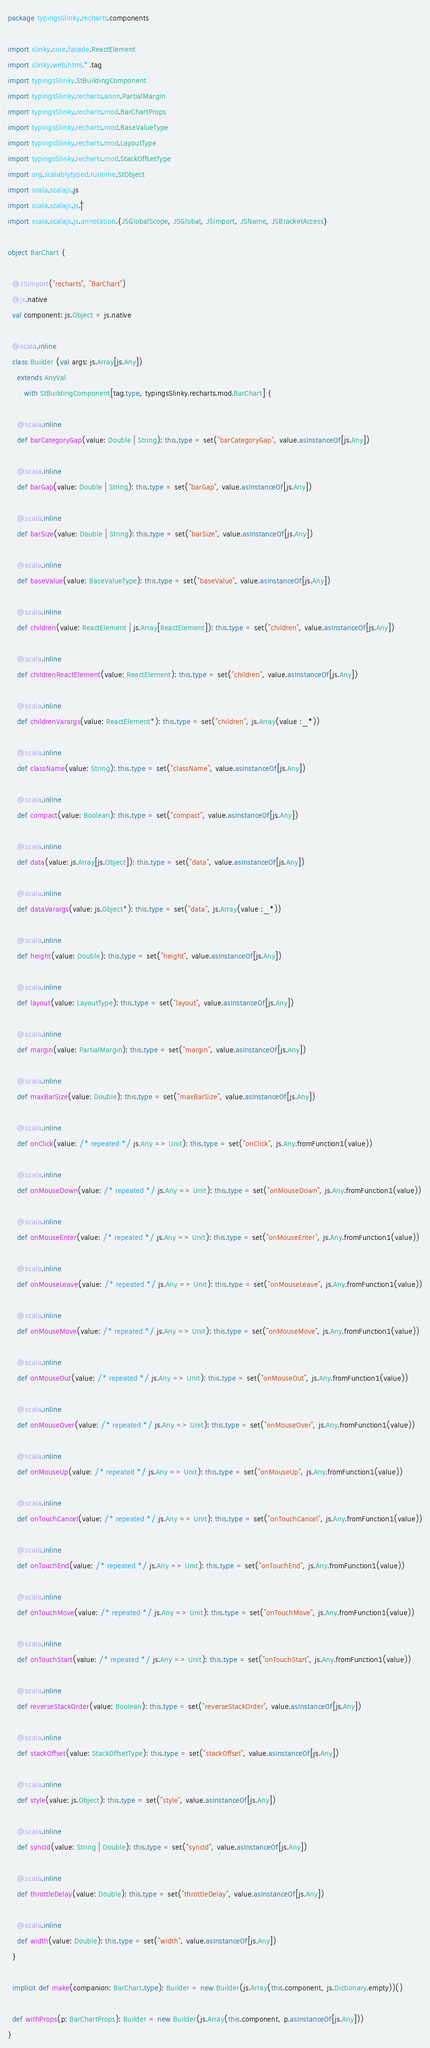<code> <loc_0><loc_0><loc_500><loc_500><_Scala_>package typingsSlinky.recharts.components

import slinky.core.facade.ReactElement
import slinky.web.html.`*`.tag
import typingsSlinky.StBuildingComponent
import typingsSlinky.recharts.anon.PartialMargin
import typingsSlinky.recharts.mod.BarChartProps
import typingsSlinky.recharts.mod.BaseValueType
import typingsSlinky.recharts.mod.LayoutType
import typingsSlinky.recharts.mod.StackOffsetType
import org.scalablytyped.runtime.StObject
import scala.scalajs.js
import scala.scalajs.js.`|`
import scala.scalajs.js.annotation.{JSGlobalScope, JSGlobal, JSImport, JSName, JSBracketAccess}

object BarChart {
  
  @JSImport("recharts", "BarChart")
  @js.native
  val component: js.Object = js.native
  
  @scala.inline
  class Builder (val args: js.Array[js.Any])
    extends AnyVal
       with StBuildingComponent[tag.type, typingsSlinky.recharts.mod.BarChart] {
    
    @scala.inline
    def barCategoryGap(value: Double | String): this.type = set("barCategoryGap", value.asInstanceOf[js.Any])
    
    @scala.inline
    def barGap(value: Double | String): this.type = set("barGap", value.asInstanceOf[js.Any])
    
    @scala.inline
    def barSize(value: Double | String): this.type = set("barSize", value.asInstanceOf[js.Any])
    
    @scala.inline
    def baseValue(value: BaseValueType): this.type = set("baseValue", value.asInstanceOf[js.Any])
    
    @scala.inline
    def children(value: ReactElement | js.Array[ReactElement]): this.type = set("children", value.asInstanceOf[js.Any])
    
    @scala.inline
    def childrenReactElement(value: ReactElement): this.type = set("children", value.asInstanceOf[js.Any])
    
    @scala.inline
    def childrenVarargs(value: ReactElement*): this.type = set("children", js.Array(value :_*))
    
    @scala.inline
    def className(value: String): this.type = set("className", value.asInstanceOf[js.Any])
    
    @scala.inline
    def compact(value: Boolean): this.type = set("compact", value.asInstanceOf[js.Any])
    
    @scala.inline
    def data(value: js.Array[js.Object]): this.type = set("data", value.asInstanceOf[js.Any])
    
    @scala.inline
    def dataVarargs(value: js.Object*): this.type = set("data", js.Array(value :_*))
    
    @scala.inline
    def height(value: Double): this.type = set("height", value.asInstanceOf[js.Any])
    
    @scala.inline
    def layout(value: LayoutType): this.type = set("layout", value.asInstanceOf[js.Any])
    
    @scala.inline
    def margin(value: PartialMargin): this.type = set("margin", value.asInstanceOf[js.Any])
    
    @scala.inline
    def maxBarSize(value: Double): this.type = set("maxBarSize", value.asInstanceOf[js.Any])
    
    @scala.inline
    def onClick(value: /* repeated */ js.Any => Unit): this.type = set("onClick", js.Any.fromFunction1(value))
    
    @scala.inline
    def onMouseDown(value: /* repeated */ js.Any => Unit): this.type = set("onMouseDown", js.Any.fromFunction1(value))
    
    @scala.inline
    def onMouseEnter(value: /* repeated */ js.Any => Unit): this.type = set("onMouseEnter", js.Any.fromFunction1(value))
    
    @scala.inline
    def onMouseLeave(value: /* repeated */ js.Any => Unit): this.type = set("onMouseLeave", js.Any.fromFunction1(value))
    
    @scala.inline
    def onMouseMove(value: /* repeated */ js.Any => Unit): this.type = set("onMouseMove", js.Any.fromFunction1(value))
    
    @scala.inline
    def onMouseOut(value: /* repeated */ js.Any => Unit): this.type = set("onMouseOut", js.Any.fromFunction1(value))
    
    @scala.inline
    def onMouseOver(value: /* repeated */ js.Any => Unit): this.type = set("onMouseOver", js.Any.fromFunction1(value))
    
    @scala.inline
    def onMouseUp(value: /* repeated */ js.Any => Unit): this.type = set("onMouseUp", js.Any.fromFunction1(value))
    
    @scala.inline
    def onTouchCancel(value: /* repeated */ js.Any => Unit): this.type = set("onTouchCancel", js.Any.fromFunction1(value))
    
    @scala.inline
    def onTouchEnd(value: /* repeated */ js.Any => Unit): this.type = set("onTouchEnd", js.Any.fromFunction1(value))
    
    @scala.inline
    def onTouchMove(value: /* repeated */ js.Any => Unit): this.type = set("onTouchMove", js.Any.fromFunction1(value))
    
    @scala.inline
    def onTouchStart(value: /* repeated */ js.Any => Unit): this.type = set("onTouchStart", js.Any.fromFunction1(value))
    
    @scala.inline
    def reverseStackOrder(value: Boolean): this.type = set("reverseStackOrder", value.asInstanceOf[js.Any])
    
    @scala.inline
    def stackOffset(value: StackOffsetType): this.type = set("stackOffset", value.asInstanceOf[js.Any])
    
    @scala.inline
    def style(value: js.Object): this.type = set("style", value.asInstanceOf[js.Any])
    
    @scala.inline
    def syncId(value: String | Double): this.type = set("syncId", value.asInstanceOf[js.Any])
    
    @scala.inline
    def throttleDelay(value: Double): this.type = set("throttleDelay", value.asInstanceOf[js.Any])
    
    @scala.inline
    def width(value: Double): this.type = set("width", value.asInstanceOf[js.Any])
  }
  
  implicit def make(companion: BarChart.type): Builder = new Builder(js.Array(this.component, js.Dictionary.empty))()
  
  def withProps(p: BarChartProps): Builder = new Builder(js.Array(this.component, p.asInstanceOf[js.Any]))
}
</code> 